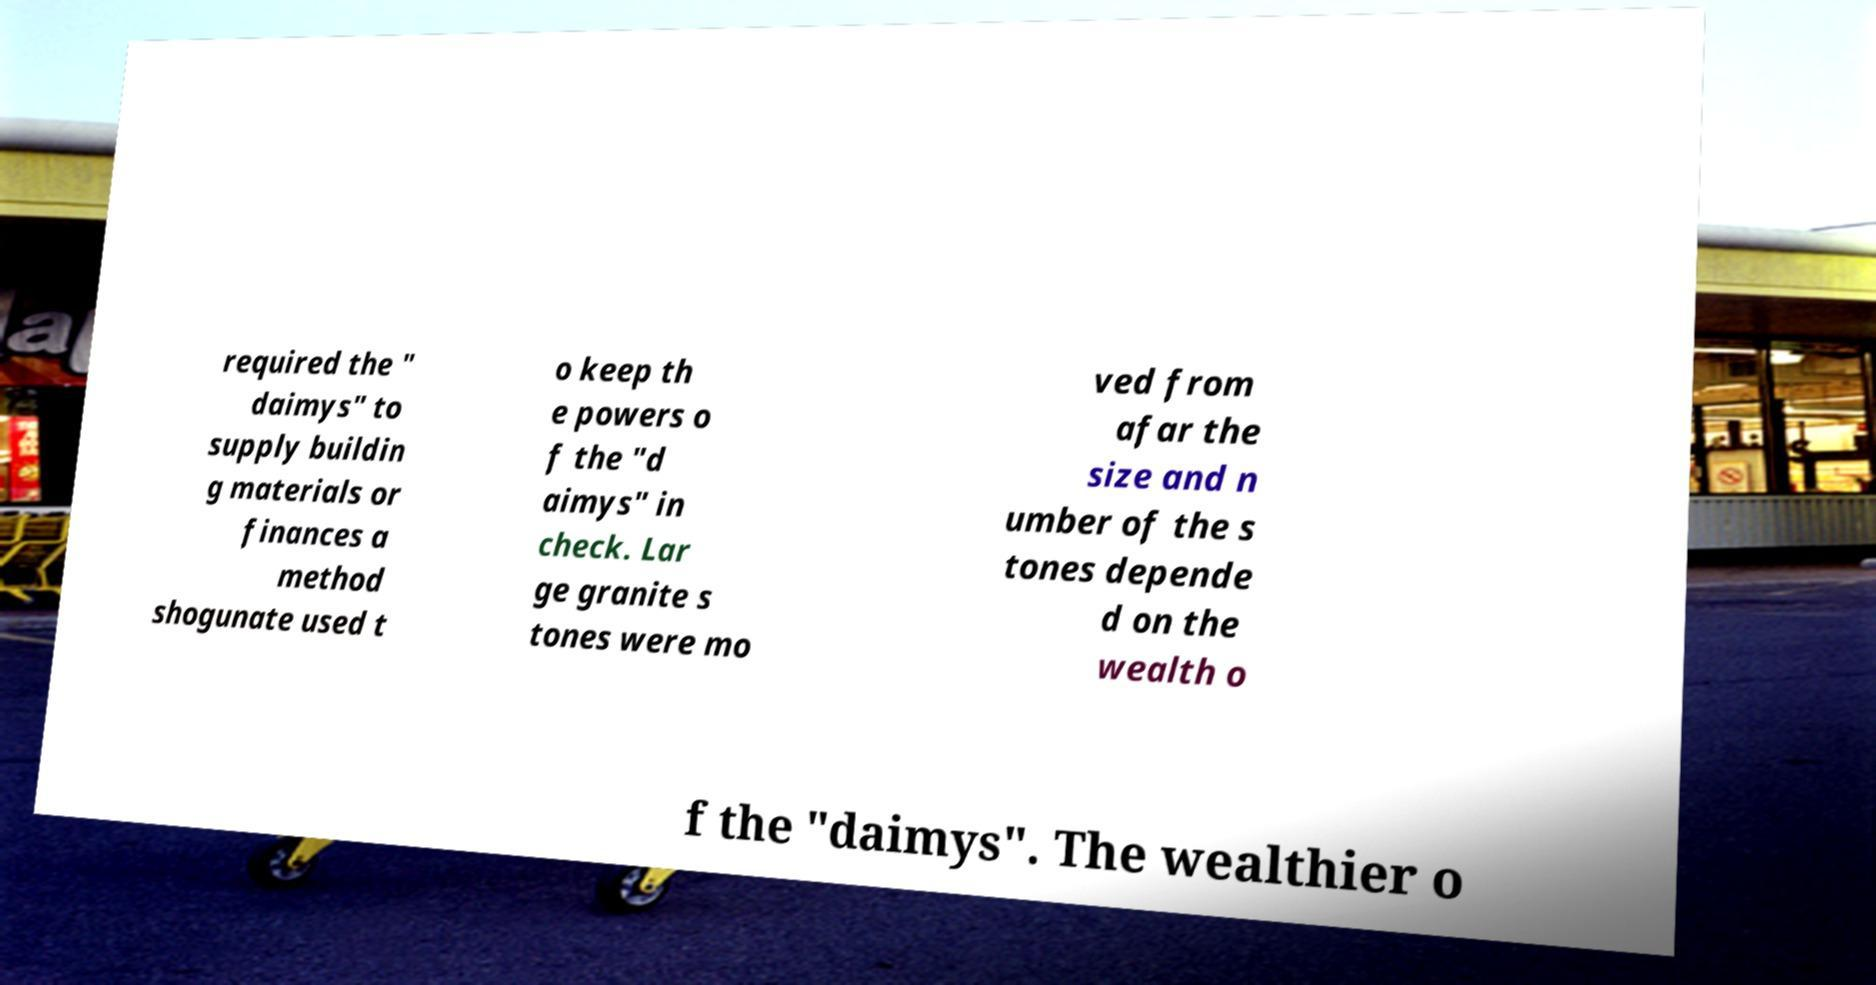I need the written content from this picture converted into text. Can you do that? required the " daimys" to supply buildin g materials or finances a method shogunate used t o keep th e powers o f the "d aimys" in check. Lar ge granite s tones were mo ved from afar the size and n umber of the s tones depende d on the wealth o f the "daimys". The wealthier o 